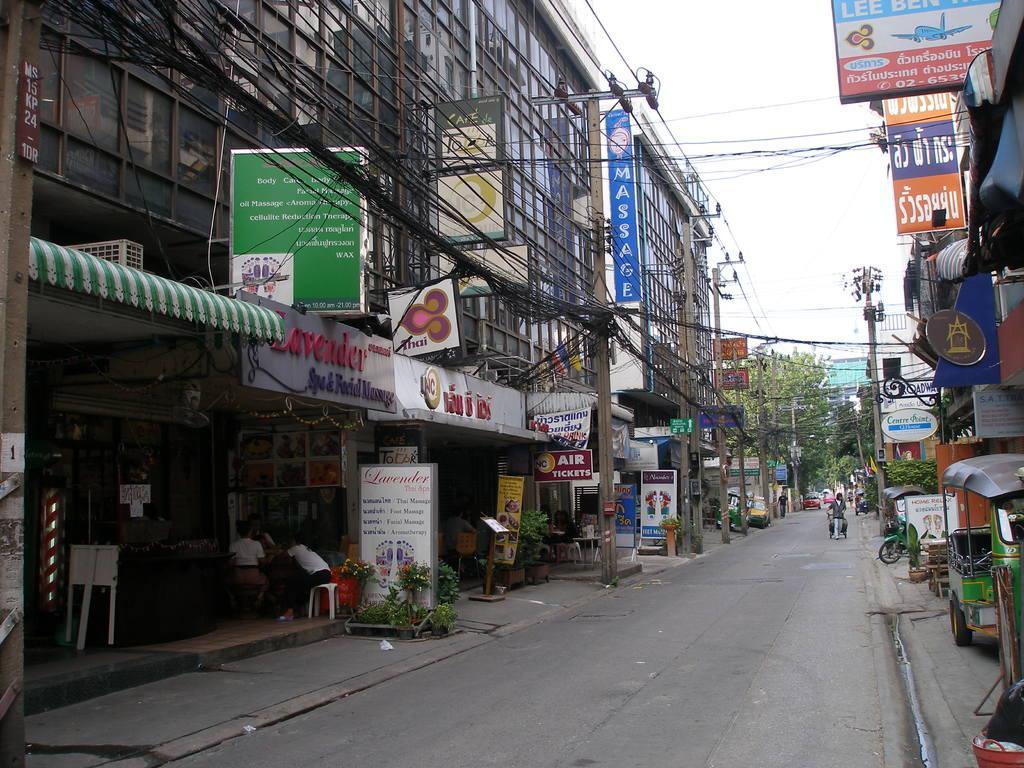Can you describe this image briefly? In this image, we can see the road, we can see some shops, there are some boards, we can see some trees, there are some places, we can see the cables, at the top there is a sky. 